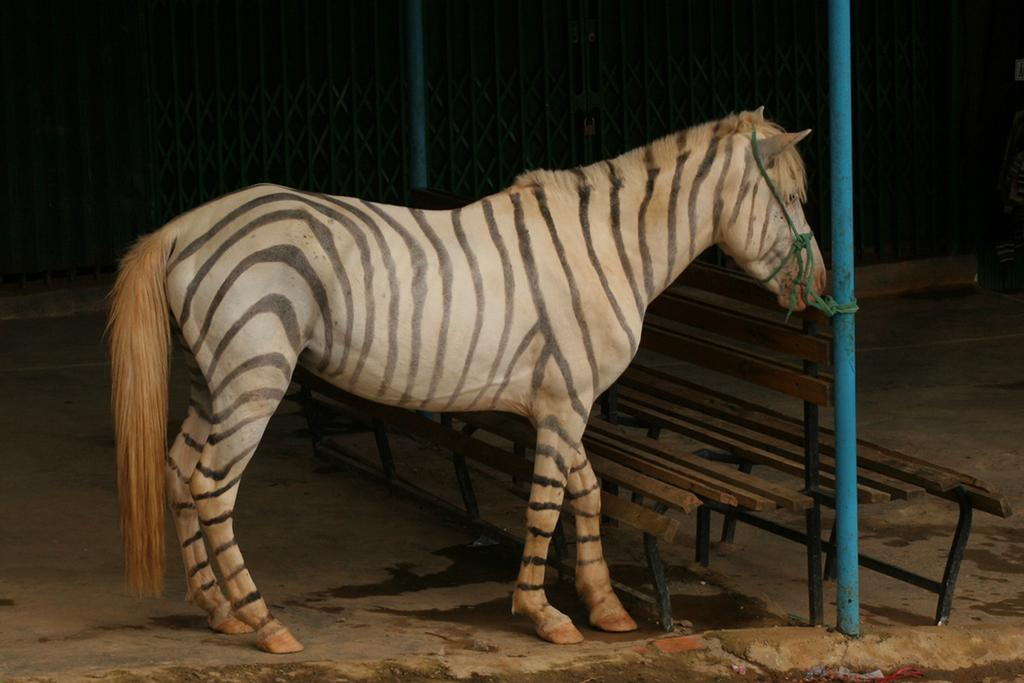What animal is in the center of the image? There is a zebra in the center of the image. How is the zebra secured in the image? The zebra is tied to a pole. What type of seating can be seen in the background of the image? There are benches in the background of the image. What can be seen cooking in the background of the image? There are grills in the background of the image. What surface is visible at the bottom of the image? There is a floor visible at the bottom of the image. What type of gate is present in the image? There is no gate present in the image; it features a zebra tied to a pole and other elements in the background. 